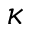<formula> <loc_0><loc_0><loc_500><loc_500>\kappa</formula> 